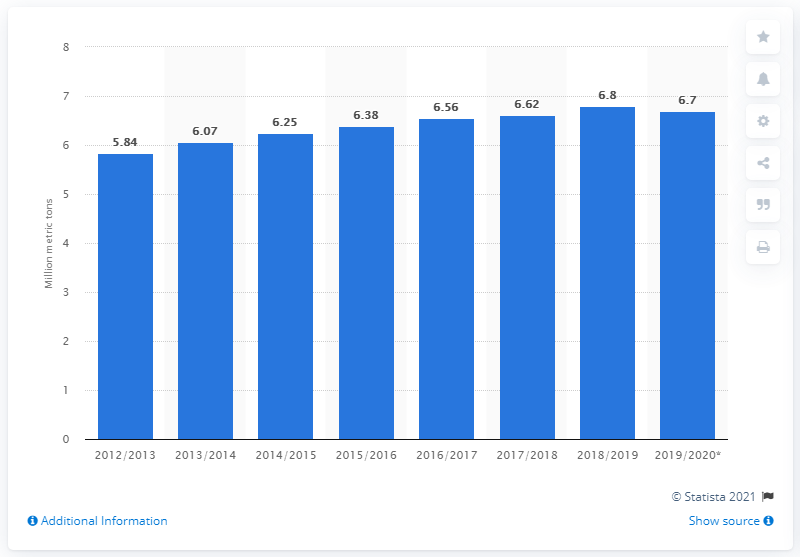Outline some significant characteristics in this image. According to the latest data, global grapefruit production in 2018/2019 was estimated to be approximately 6.8 million metric tons. 